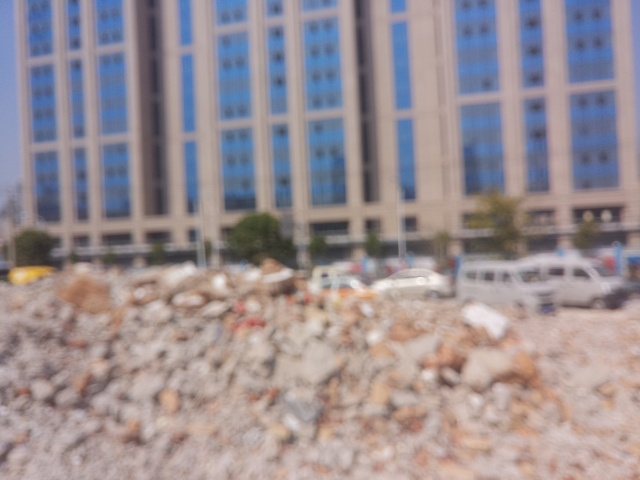What might the blurred area in the foreground represent? The blurred area in the foreground likely represents a construction or demolition site, as suggested by the scattered rubble and irregular shapes that are discernible despite the lack of focus. 